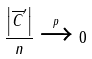Convert formula to latex. <formula><loc_0><loc_0><loc_500><loc_500>\frac { \left | \overline { C } ^ { \prime } \right | } { n } \xrightarrow { p } 0</formula> 